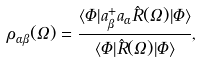Convert formula to latex. <formula><loc_0><loc_0><loc_500><loc_500>\rho _ { \alpha \beta } ( \Omega ) = \frac { \langle \Phi | a ^ { + } _ { \beta } a _ { \alpha } \hat { R } ( \Omega ) | \Phi \rangle } { \langle \Phi | \hat { R } ( \Omega ) | \Phi \rangle } ,</formula> 